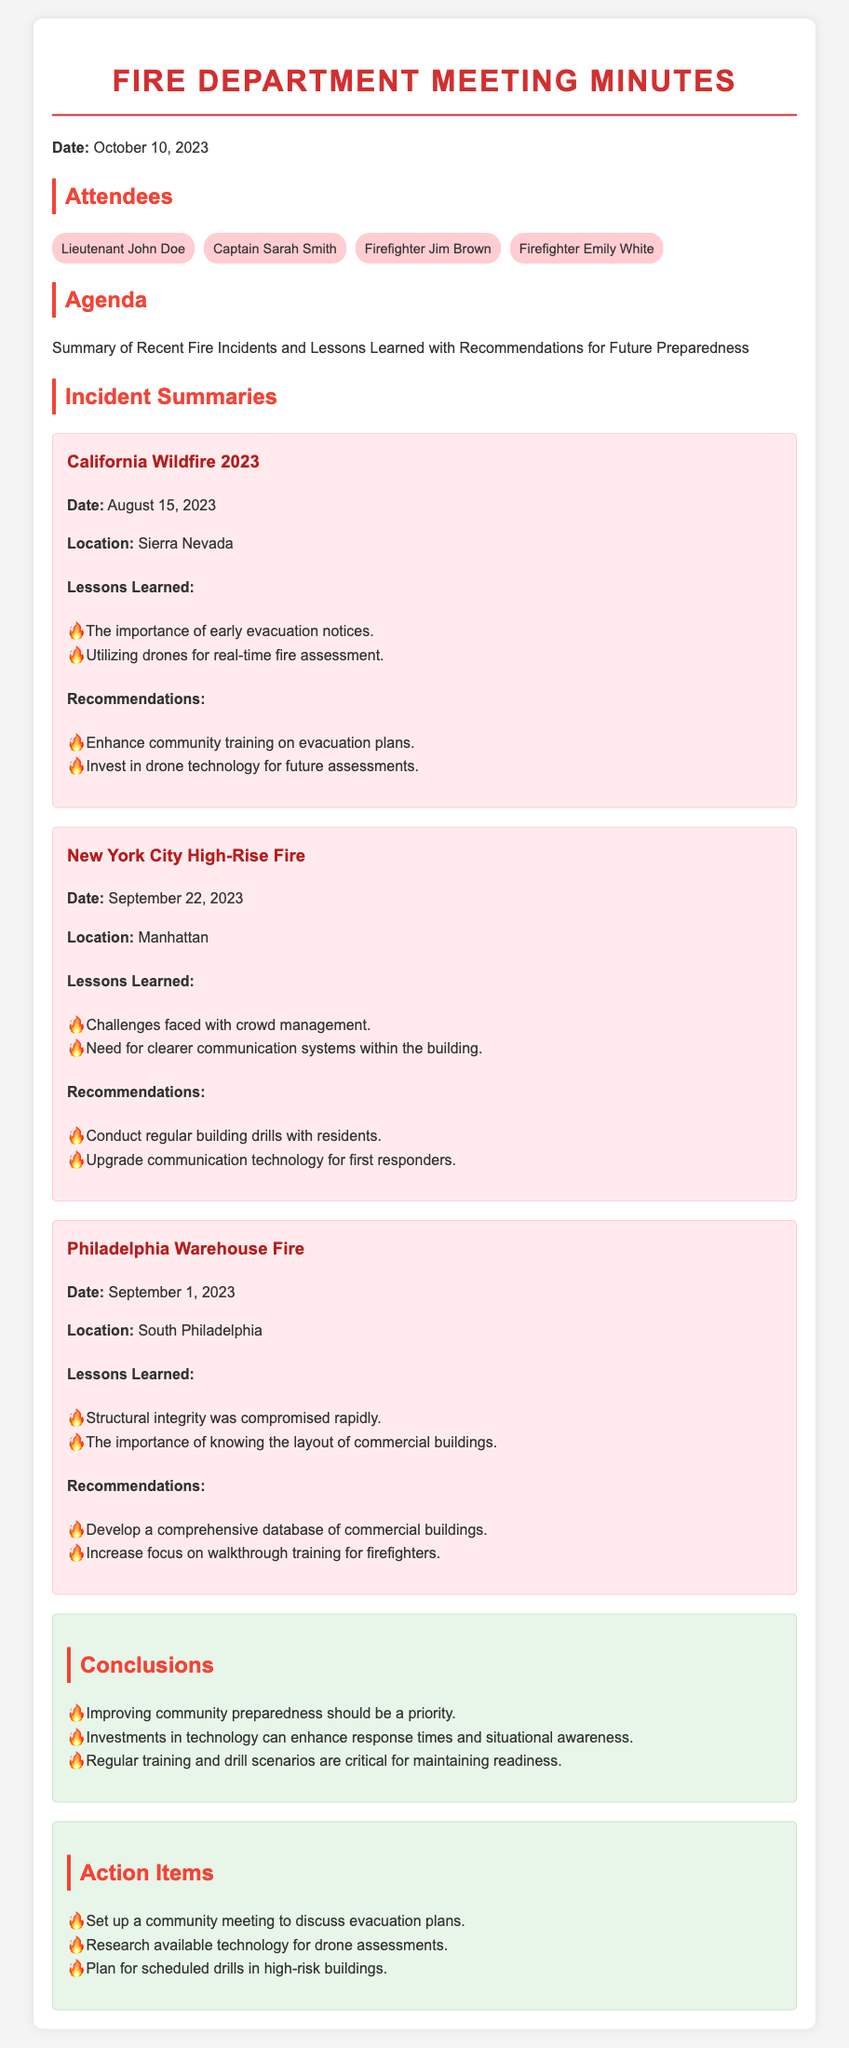what was the date of the meeting? The meeting took place on October 10, 2023, as stated in the document.
Answer: October 10, 2023 who presented the New York City High-Rise Fire incident? The document lists the summary of the New York City High-Rise Fire incident without specifying an individual presenter.
Answer: Not specified what was one of the lessons learned from the Philadelphia Warehouse Fire? The document mentions two lessons learned from the Philadelphia Warehouse Fire, and one is about structural integrity.
Answer: Structural integrity was compromised rapidly how many incidents were summarized in the meeting? The document summarizes three incidents, each corresponding to a fire event.
Answer: Three what recommendation was made for the California Wildfire? The document recommends community training on evacuation plans as one of the recommendations related to California Wildfire.
Answer: Enhance community training on evacuation plans which location had a fire incident on September 1, 2023? The incident on September 1, 2023, took place in South Philadelphia, as per the incident summary.
Answer: South Philadelphia what is one action item mentioned in the document? The document lists several action items; one of them is about community meetings.
Answer: Set up a community meeting to discuss evacuation plans what is the primary focus of the Conclusions section? The Conclusions section primarily focuses on the importance of preparedness and technology in fire response, which can be inferred from the overall conclusions.
Answer: Improving community preparedness should be a priority 